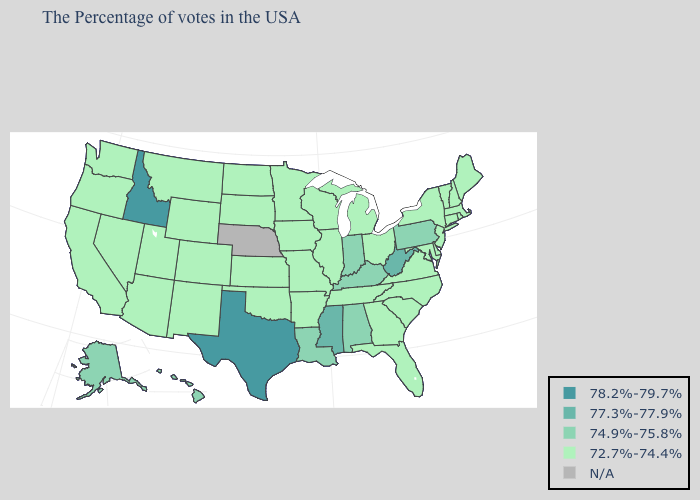What is the value of Georgia?
Write a very short answer. 72.7%-74.4%. What is the value of Louisiana?
Quick response, please. 74.9%-75.8%. Name the states that have a value in the range N/A?
Be succinct. Nebraska. Name the states that have a value in the range N/A?
Write a very short answer. Nebraska. Among the states that border Louisiana , which have the lowest value?
Quick response, please. Arkansas. Does the map have missing data?
Answer briefly. Yes. Which states have the lowest value in the USA?
Answer briefly. Maine, Massachusetts, Rhode Island, New Hampshire, Vermont, Connecticut, New York, New Jersey, Delaware, Maryland, Virginia, North Carolina, South Carolina, Ohio, Florida, Georgia, Michigan, Tennessee, Wisconsin, Illinois, Missouri, Arkansas, Minnesota, Iowa, Kansas, Oklahoma, South Dakota, North Dakota, Wyoming, Colorado, New Mexico, Utah, Montana, Arizona, Nevada, California, Washington, Oregon. How many symbols are there in the legend?
Give a very brief answer. 5. Among the states that border Connecticut , which have the lowest value?
Write a very short answer. Massachusetts, Rhode Island, New York. How many symbols are there in the legend?
Be succinct. 5. What is the highest value in states that border Idaho?
Give a very brief answer. 72.7%-74.4%. What is the value of Alabama?
Keep it brief. 74.9%-75.8%. 